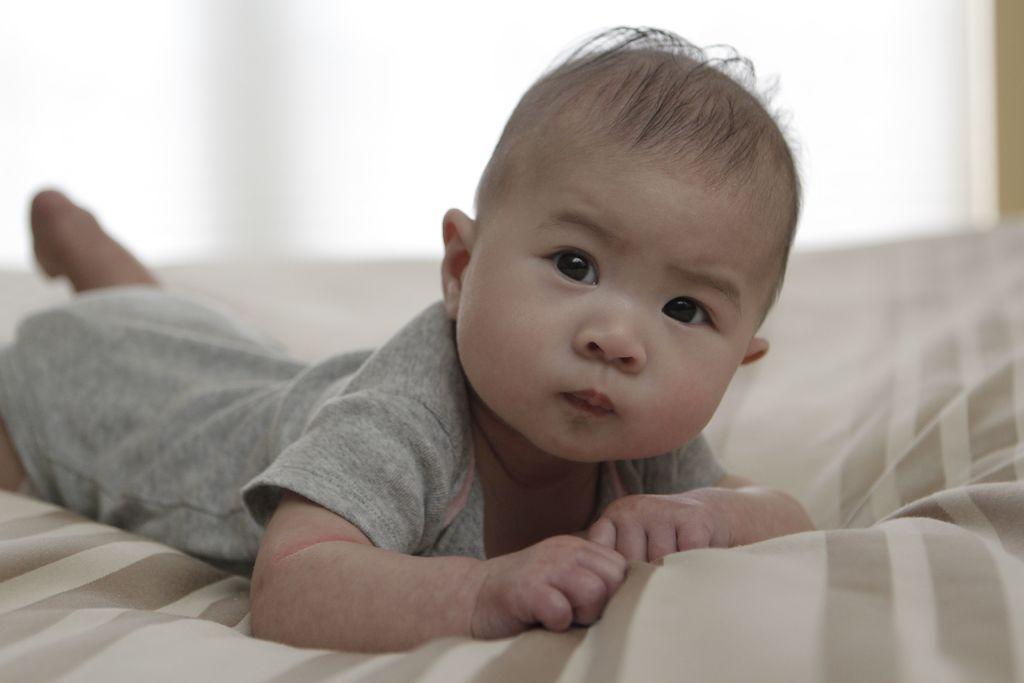Can you describe this image briefly? There is a baby lying on bed. 